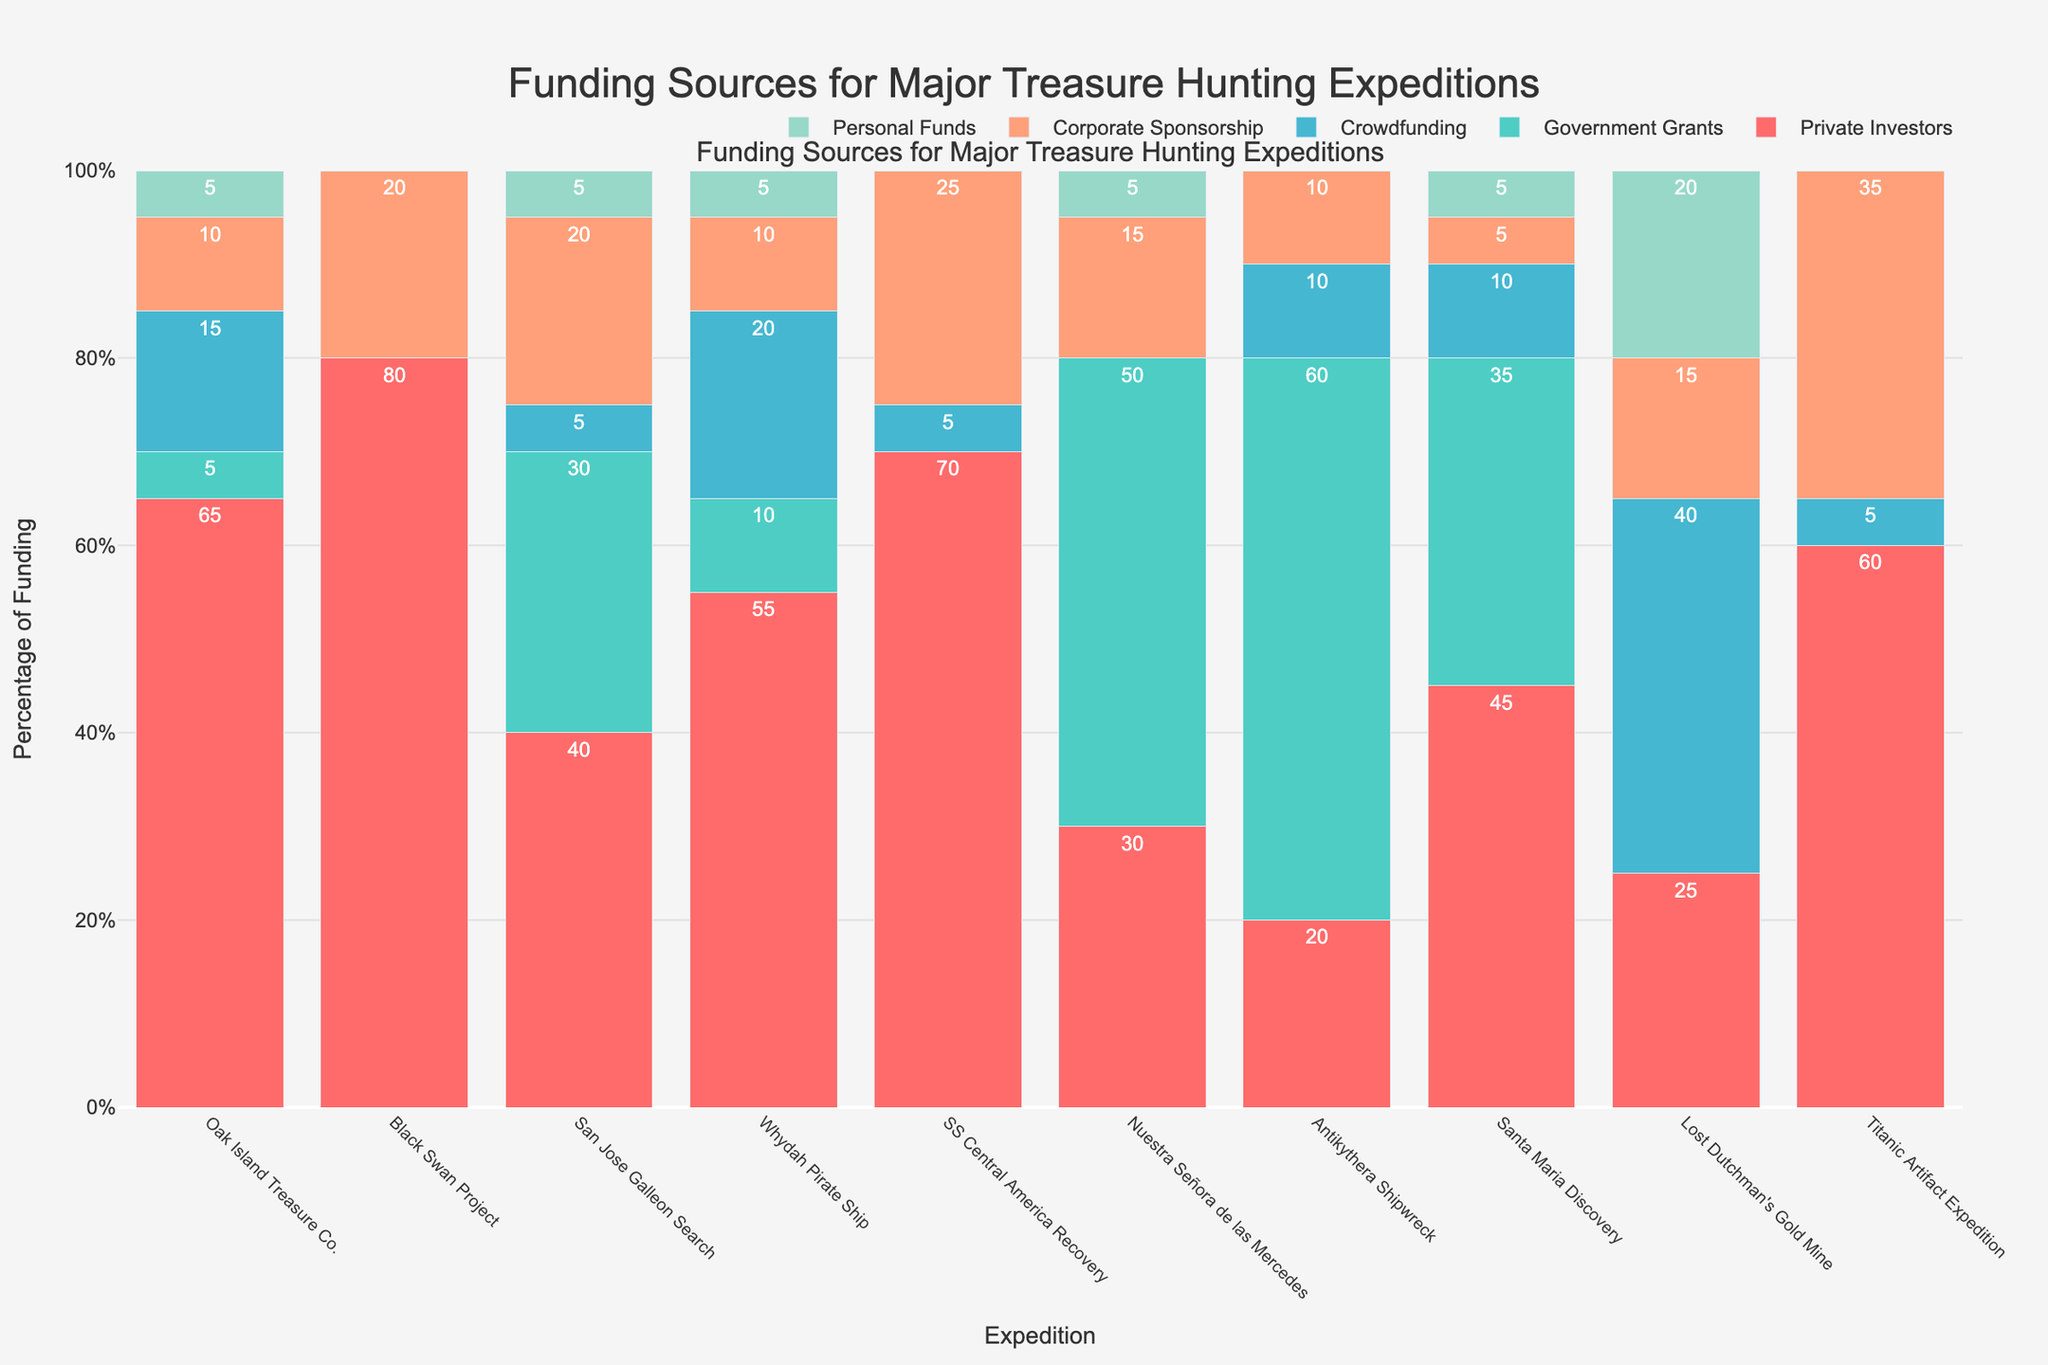Which expedition received the highest percentage of funding from private investors? The bar chart shows that the Black Swan Project received the highest percentage of funding from private investors, with 80%.
Answer: Black Swan Project Which funding source is most common across the majority of expeditions? By examining the lengths of the bars, Private Investors consistently show tall bars across most expeditions, indicating it is the most common funding source.
Answer: Private Investors What is the difference in government grants between the San Jose Galleon Search and the Antikythera Shipwreck expeditions? The bar for government grants is 30% for the San Jose Galleon Search and 60% for the Antikythera Shipwreck. The difference is 60% - 30% = 30%.
Answer: 30% Which expedition had the highest percentage of crowdfunding and what is that percentage? The bar chart indicates that the Lost Dutchman's Gold Mine expedition had the highest percentage of crowdfunding with 40%.
Answer: Lost Dutchman's Gold Mine, 40% Compare the corporate sponsorship percentages between Oak Island Treasure Co. and SS Central America Recovery. Which one is higher and by how much? The Oak Island Treasure Co. has 10% in corporate sponsorship while SS Central America Recovery has 25%. The difference is 25% - 10% = 15%, with SS Central America Recovery being higher.
Answer: SS Central America Recovery, 15% What is the total percentage of personal funds across all expeditions in the chart? Adding each percentage of personal funds: 5% (Oak Island) + 0% (Black Swan) + 5% (San Jose) + 5% (Whydah) + 0% (SS Central America) + 5% (Nuestra Señora) + 0% (Antikythera) + 5% (Santa Maria) + 20% (Lost Dutchman's) + 0% (Titanic) = 45%.
Answer: 45% Which two expeditions received the same percentage of private investors' funding, and what is that percentage? Both Santa Maria Discovery and Antikythera Shipwreck received 20% funding from private investors.
Answer: Santa Maria Discovery, Antikythera Shipwreck, 20% What is the average percentage of government grants received by the expeditions that have any government grants? Only expeditions with government grants are: San Jose Galleon Search (30%), Whydah Pirate Ship (10%), Nuestra Señora de las Mercedes (50%), Antikythera Shipwreck (60%), and Santa Maria Discovery (35%). The average is (30% + 10% + 50% + 60% + 35%) / 5 = 37%.
Answer: 37% Which expedition had the lowest percentage of funding from private investors? The bar chart shows that the Antikythera Shipwreck had the lowest percentage from private investors, with 20%.
Answer: Antikythera Shipwreck What percentage of total funding does crowdfunding contribute to the Nuestra Señora de las Mercedes expedition? The crowdfunding percentage for the Nuestra Señora de las Mercedes expedition is 0%, as shown by the absence of a bar in this category.
Answer: 0% 